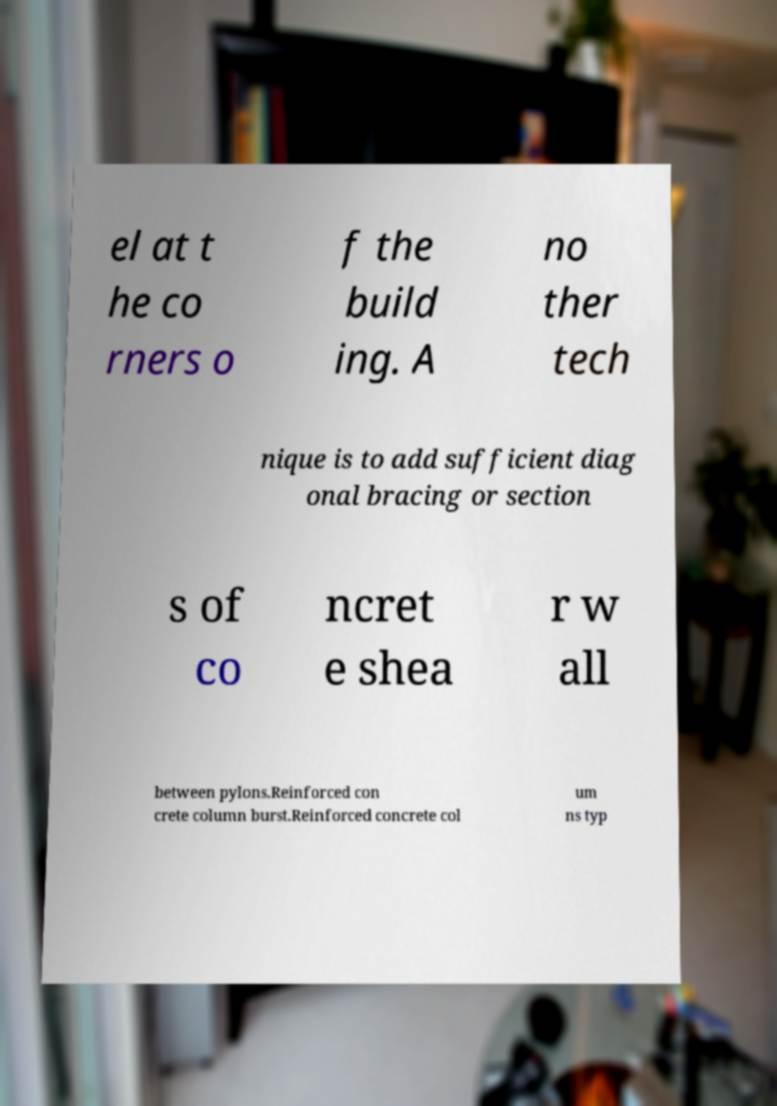Please identify and transcribe the text found in this image. el at t he co rners o f the build ing. A no ther tech nique is to add sufficient diag onal bracing or section s of co ncret e shea r w all between pylons.Reinforced con crete column burst.Reinforced concrete col um ns typ 